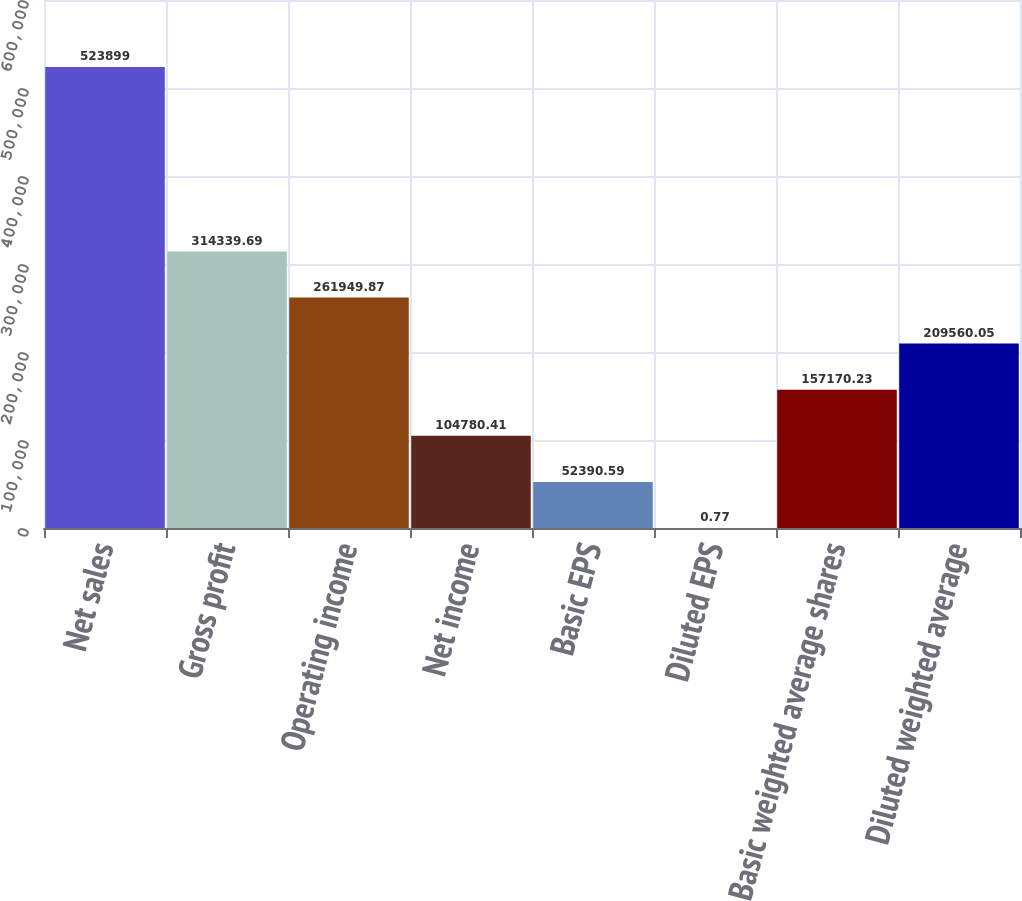<chart> <loc_0><loc_0><loc_500><loc_500><bar_chart><fcel>Net sales<fcel>Gross profit<fcel>Operating income<fcel>Net income<fcel>Basic EPS<fcel>Diluted EPS<fcel>Basic weighted average shares<fcel>Diluted weighted average<nl><fcel>523899<fcel>314340<fcel>261950<fcel>104780<fcel>52390.6<fcel>0.77<fcel>157170<fcel>209560<nl></chart> 